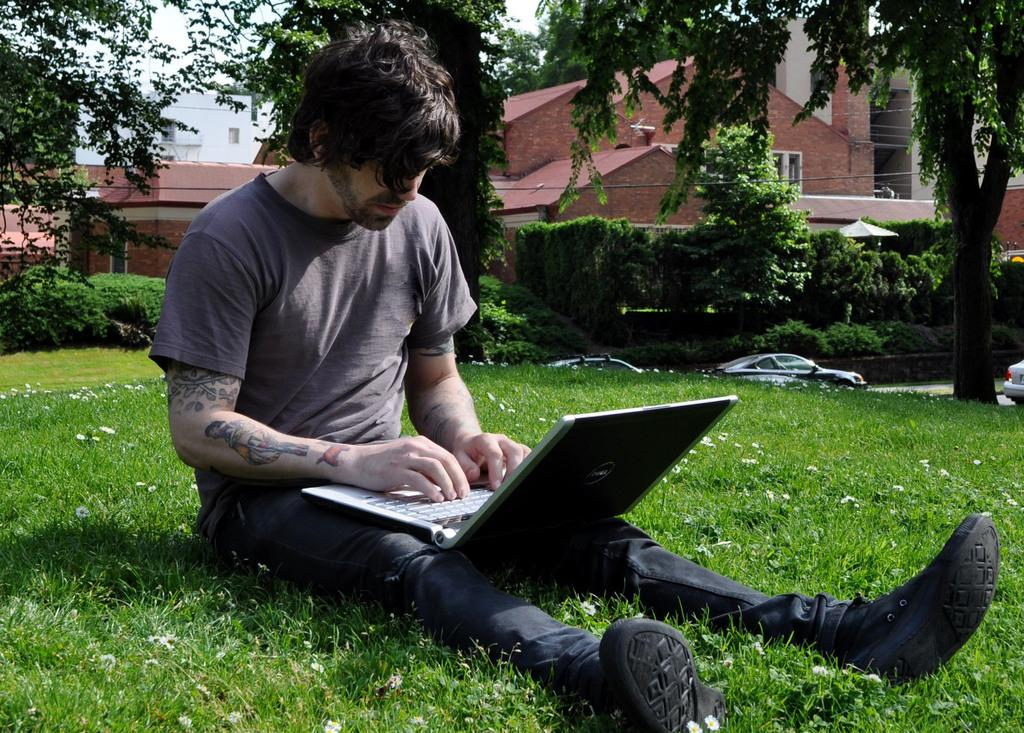What is the main subject in the foreground of the image? There is a man in the foreground of the image. What is the man doing in the image? The man is sitting on the grass. What object is the man holding in the image? The man is holding a laptop. What can be seen in the background of the image? There are trees, buildings, vehicles moving on the road, and the sky visible in the background of the image. Where is the scarecrow located in the image? There is no scarecrow present in the image. What event is taking place in the image, such as a birth or a celebration? The image does not depict any specific event like a birth or a celebration; it simply shows a man sitting on the grass with a laptop. 